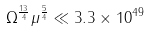Convert formula to latex. <formula><loc_0><loc_0><loc_500><loc_500>\Omega ^ { \frac { 1 3 } { 4 } } \mu ^ { \frac { 5 } { 4 } } \ll 3 . 3 \times 1 0 ^ { 4 9 }</formula> 